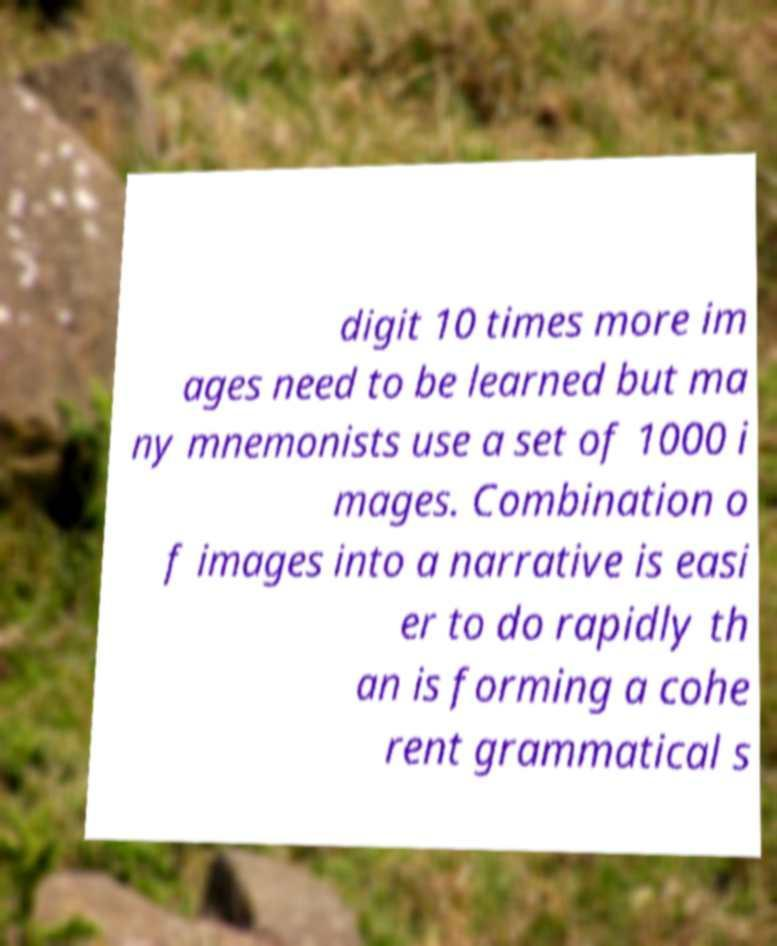Please identify and transcribe the text found in this image. digit 10 times more im ages need to be learned but ma ny mnemonists use a set of 1000 i mages. Combination o f images into a narrative is easi er to do rapidly th an is forming a cohe rent grammatical s 